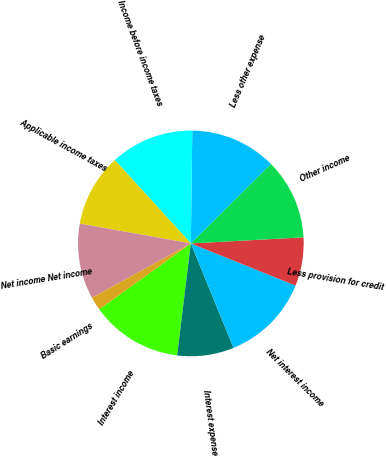Convert chart to OTSL. <chart><loc_0><loc_0><loc_500><loc_500><pie_chart><fcel>Interest income<fcel>Interest expense<fcel>Net interest income<fcel>Less provision for credit<fcel>Other income<fcel>Less other expense<fcel>Income before income taxes<fcel>Applicable income taxes<fcel>Net income Net income<fcel>Basic earnings<nl><fcel>13.13%<fcel>8.11%<fcel>12.74%<fcel>6.95%<fcel>11.58%<fcel>12.36%<fcel>11.97%<fcel>10.42%<fcel>10.81%<fcel>1.93%<nl></chart> 